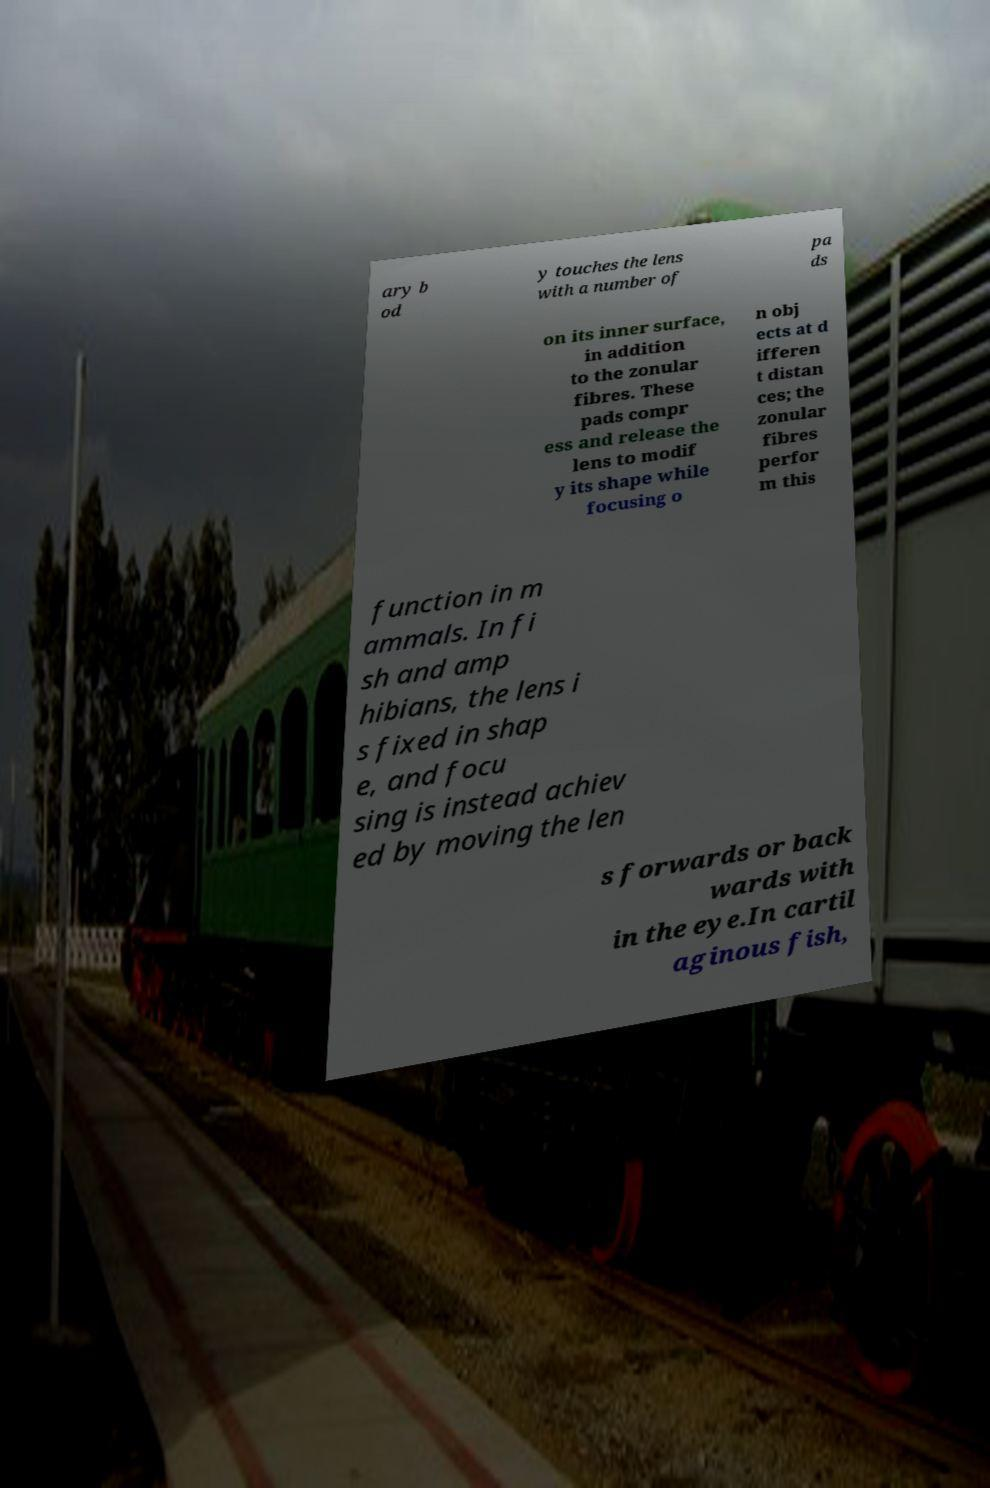I need the written content from this picture converted into text. Can you do that? ary b od y touches the lens with a number of pa ds on its inner surface, in addition to the zonular fibres. These pads compr ess and release the lens to modif y its shape while focusing o n obj ects at d ifferen t distan ces; the zonular fibres perfor m this function in m ammals. In fi sh and amp hibians, the lens i s fixed in shap e, and focu sing is instead achiev ed by moving the len s forwards or back wards with in the eye.In cartil aginous fish, 